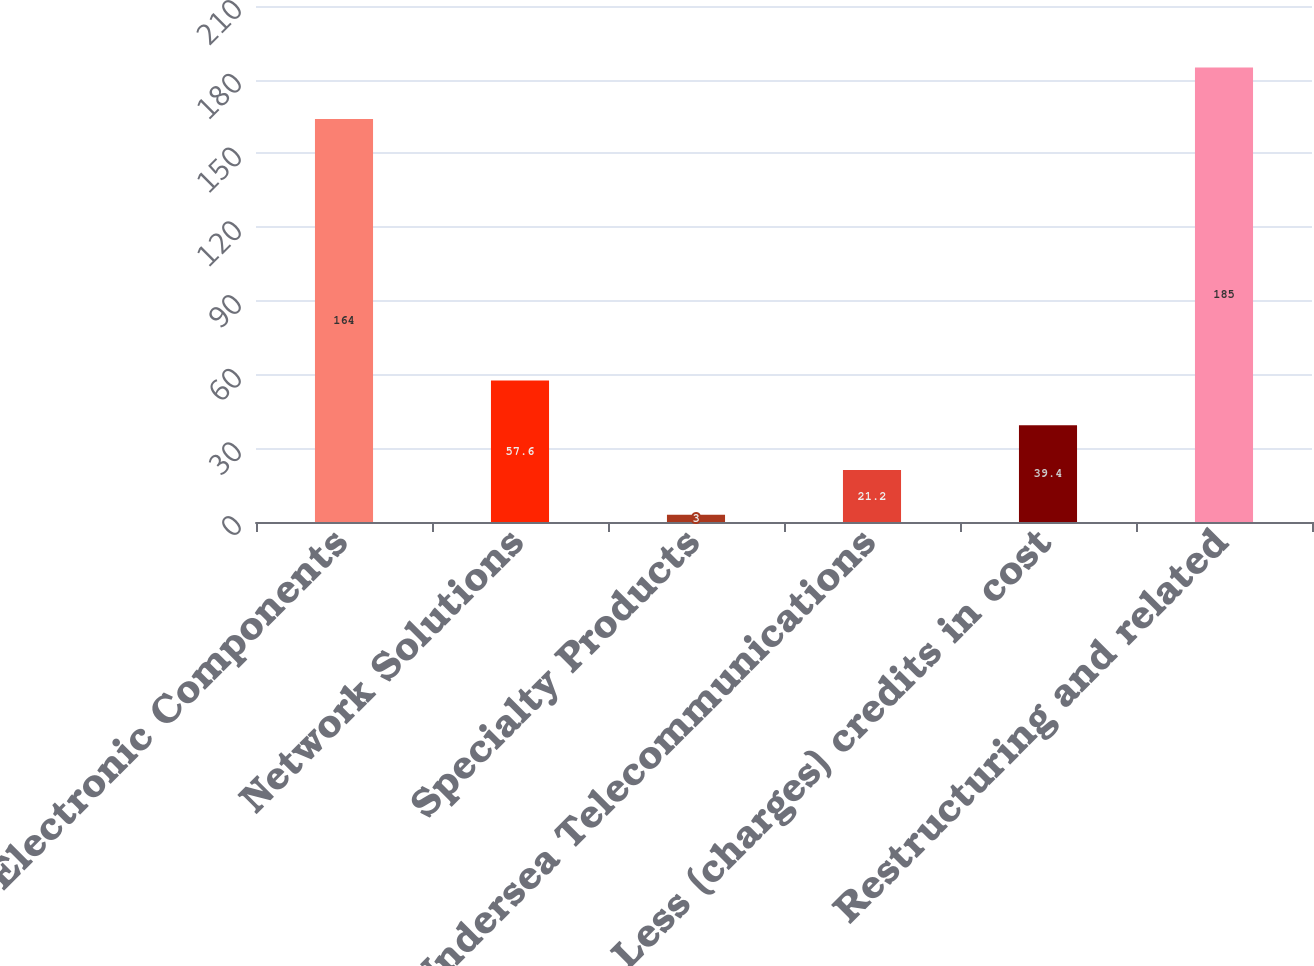Convert chart. <chart><loc_0><loc_0><loc_500><loc_500><bar_chart><fcel>Electronic Components<fcel>Network Solutions<fcel>Specialty Products<fcel>Undersea Telecommunications<fcel>Less (charges) credits in cost<fcel>Restructuring and related<nl><fcel>164<fcel>57.6<fcel>3<fcel>21.2<fcel>39.4<fcel>185<nl></chart> 